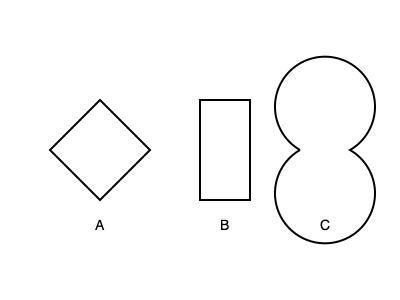Which combination of kitchen utensils, when mentally rotated and assembled, would form a chef's hat shape? To solve this problem, we need to analyze each shape and consider how they might represent kitchen utensils:

1. Shape A: This diamond shape could represent a folded napkin or a diamond-shaped cookie cutter.
2. Shape B: This rectangle could represent a cutting board or a spatula.
3. Shape C: This circle could represent a plate, a round cake pan, or the top view of a stockpot.

To form a chef's hat shape, we need:
1. A wide, circular base (represented by Shape C)
2. A tall, slightly tapered middle section (can be formed by rotating Shape B vertically)
3. A slightly wider top (can be achieved by placing Shape A on top, rotated 45 degrees)

Step-by-step assembly:
1. Start with Shape C as the base of the hat.
2. Rotate Shape B 90 degrees clockwise to make it vertical, and place it on top of Shape C. This forms the tall middle section of the hat.
3. Rotate Shape A 45 degrees in either direction and place it on top of Shape B. This creates the slightly wider top of the chef's hat.

The resulting combination, when mentally assembled, would resemble the classic tall, slightly tapered shape of a chef's hat with a wide base and a slightly wider top.
Answer: C, B (rotated 90°), A (rotated 45°) 